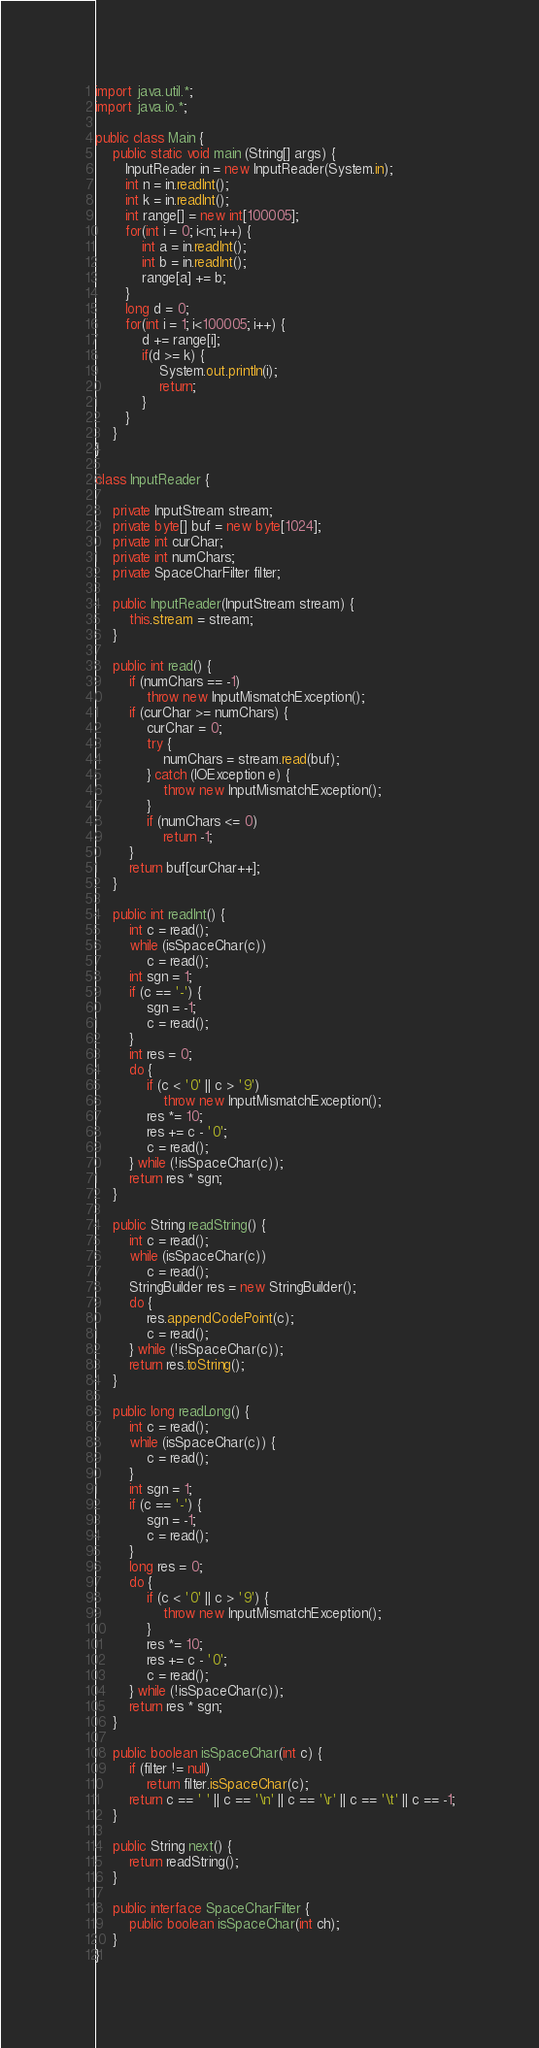Convert code to text. <code><loc_0><loc_0><loc_500><loc_500><_Java_>import java.util.*;
import java.io.*;

public class Main {
	public static void main (String[] args) {
	   InputReader in = new InputReader(System.in);
	   int n = in.readInt();
	   int k = in.readInt();
	   int range[] = new int[100005]; 
	   for(int i = 0; i<n; i++) {
		   int a = in.readInt();
		   int b = in.readInt();
		   range[a] += b; 
	   }
	   long d = 0; 
	   for(int i = 1; i<100005; i++) {
		   d += range[i]; 
		   if(d >= k) {
			   System.out.println(i);
			   return; 
		   }
	   }
	}
}

class InputReader {

	private InputStream stream;
	private byte[] buf = new byte[1024];
	private int curChar;
	private int numChars;
	private SpaceCharFilter filter;

	public InputReader(InputStream stream) {
		this.stream = stream;
	}

	public int read() {
		if (numChars == -1)
			throw new InputMismatchException();
		if (curChar >= numChars) {
			curChar = 0;
			try {
				numChars = stream.read(buf);
			} catch (IOException e) {
				throw new InputMismatchException();
			}
			if (numChars <= 0)
				return -1;
		}
		return buf[curChar++];
	}

	public int readInt() {
		int c = read();
		while (isSpaceChar(c))
			c = read();
		int sgn = 1;
		if (c == '-') {
			sgn = -1;
			c = read();
		}
		int res = 0;
		do {
			if (c < '0' || c > '9')
				throw new InputMismatchException();
			res *= 10;
			res += c - '0';
			c = read();
		} while (!isSpaceChar(c));
		return res * sgn;
	}

	public String readString() {
		int c = read();
		while (isSpaceChar(c))
			c = read();
		StringBuilder res = new StringBuilder();
		do {
			res.appendCodePoint(c);
			c = read();
		} while (!isSpaceChar(c));
		return res.toString();
	}

	public long readLong() {
		int c = read();
		while (isSpaceChar(c)) {
			c = read();
		}
		int sgn = 1;
		if (c == '-') {
			sgn = -1;
			c = read();
		}
		long res = 0;
		do {
			if (c < '0' || c > '9') {
				throw new InputMismatchException();
			}
			res *= 10;
			res += c - '0';
			c = read();
		} while (!isSpaceChar(c));
		return res * sgn;
	}
	
	public boolean isSpaceChar(int c) {
		if (filter != null)
			return filter.isSpaceChar(c);
		return c == ' ' || c == '\n' || c == '\r' || c == '\t' || c == -1;
	}

	public String next() {
		return readString();
	}

	public interface SpaceCharFilter {
		public boolean isSpaceChar(int ch);
	}
}
</code> 